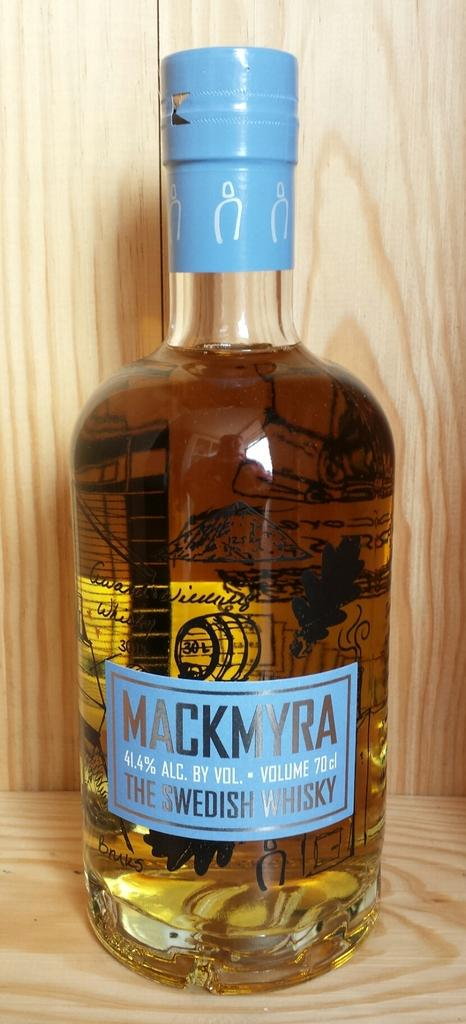<image>
Present a compact description of the photo's key features. A large bottle of Mackmyra dark Swedish whisky 